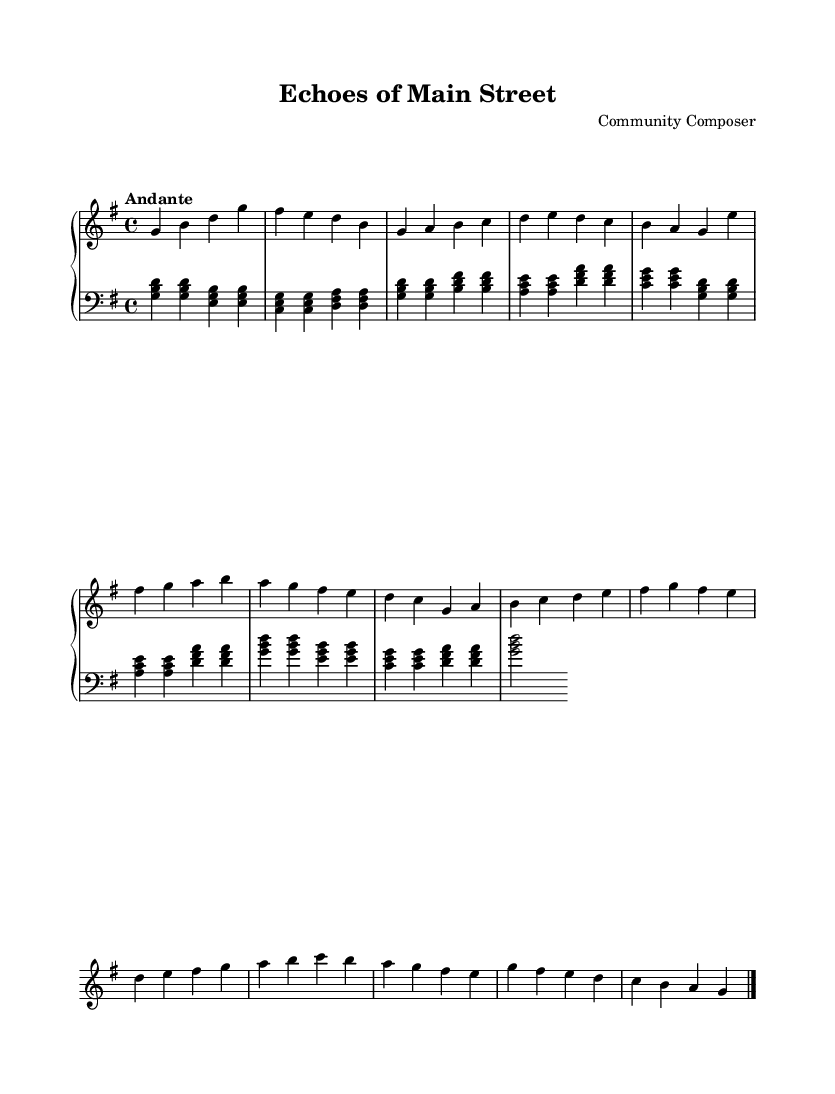What is the key signature of this music? The key signature indicates that the piece is in G major, which has one sharp (F#). This can be seen at the beginning of the staff where the sharp is placed on the F line.
Answer: G major What is the time signature of this piece? The time signature is found at the beginning of the piece, represented by the two numbers stacked vertically. Here, it shows a 4 over 4, which indicates common time.
Answer: 4/4 What is the tempo marking given in the sheet music? The tempo marking is specified as "Andante" at the start of the score, indicating a moderate pace. This term traditionally denotes a walking speed.
Answer: Andante How many themes are present in this composition? The piece features two distinct themes labeled as Theme A and Theme B, as indicated in the structure of the score. These are further elaborated in variations as well.
Answer: Two What types of chords are primarily used in the left hand? The left hand part is based on a typical chord progression involving triads (three-note chords). The score shows examples of major and minor triads which consist of root, third, and fifth notes.
Answer: Triads What is the main structural form of this composition? The form of the piece includes an introduction, two main themes (A and B), variations of both themes, and a coda, which is a common structure in Baroque music calling back to earlier material.
Answer: Theme and Variation What style of music is reflected in this composition? The music exhibits characteristics typical of the Baroque style, which includes ornamentation and emphasis on harmony and counterpoint, reflecting the historical practices of the period.
Answer: Baroque 